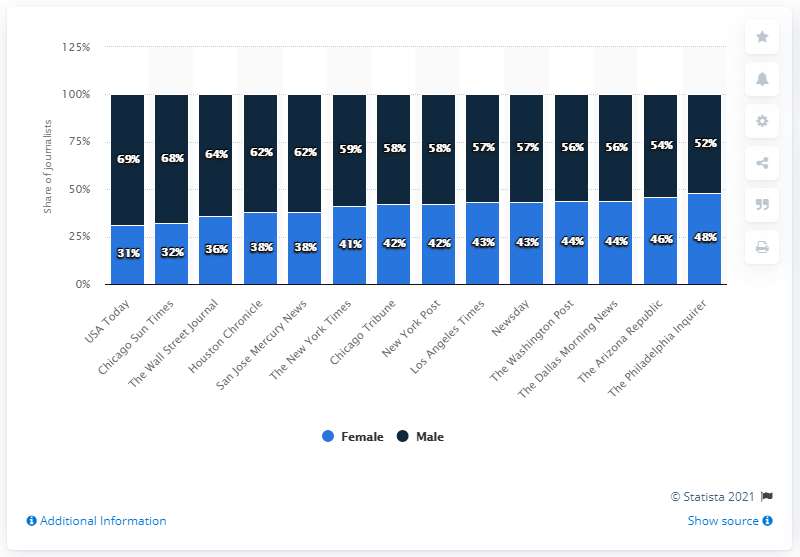Specify some key components in this picture. USA Today had the lowest percentage of female journalists among the publications examined. 